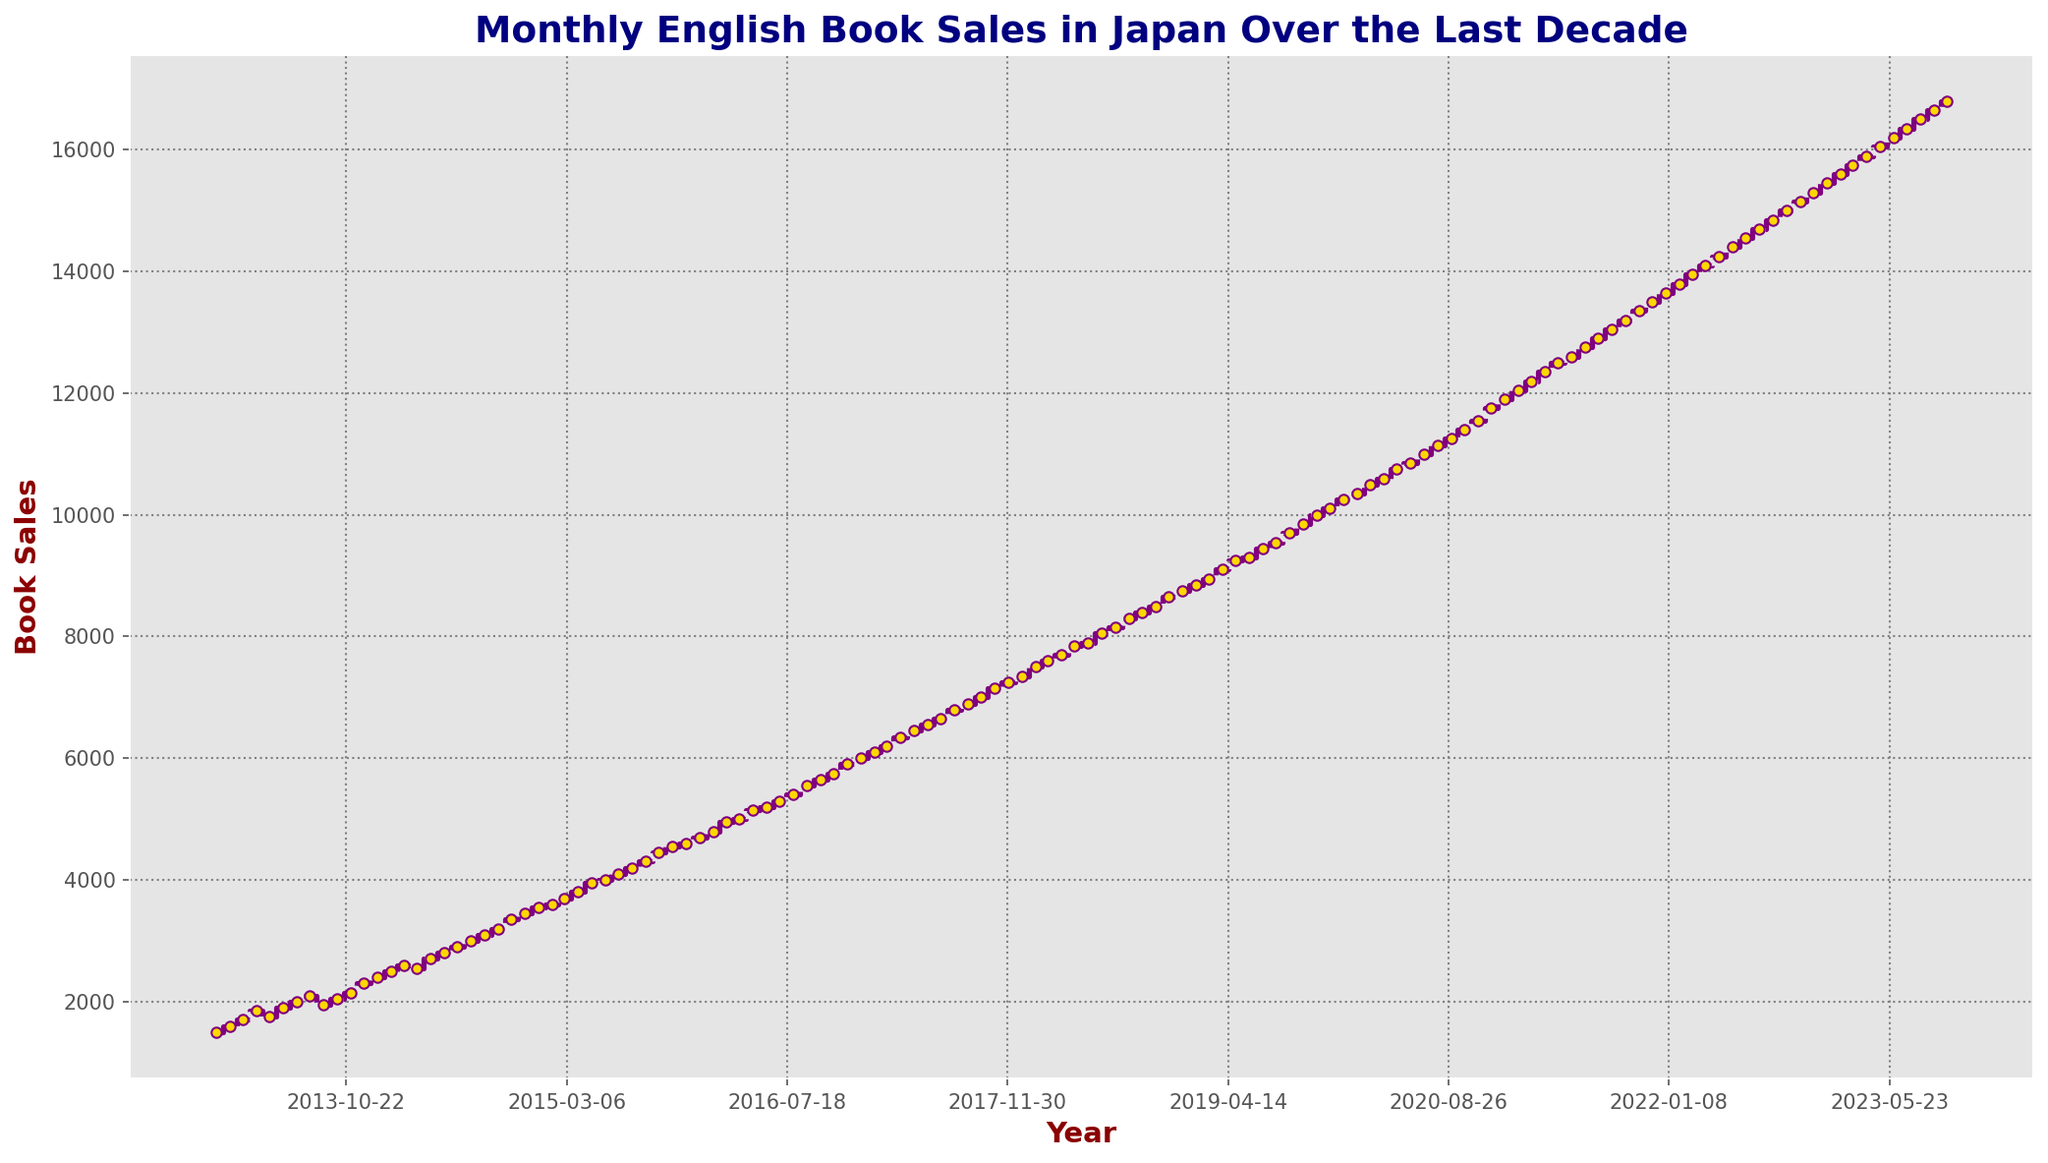How does the book sales trend from January 2015 to January 2017 look? The figure shows the monthly book sales. Moving from January 2015 to January 2017, examine the sales data points and observe their general direction. The sales figures increase over time, indicating an upward trend.
Answer: Upward trend Which month in 2020 saw the highest book sales? Look for the peak point in the 2020 line of the figure. According to the plot, December 2020 shows the peak sales figure for the year.
Answer: December Comparing July 2013 and July 2023, which month had higher book sales, and by how much? Identify the sales value for July 2013 and July 2023. July 2013 had around 2000 book sales, and July 2023 had around 16350. The difference is calculated as 16350 - 2000 = 14350.
Answer: July 2023 by 14350 What is the overall trend from 2013 to 2023? Observe the entire scale of the figure from the beginning to the end. The book sales line generally rises throughout the decade, showing an overall upward trend.
Answer: Upward trend In which year the sales crossed the 10000 mark for the first time? Locate the point in the plot where the sales line crosses the 10000 mark. According to the figure, this event happens in 2019.
Answer: 2019 By approximately how many sales did books sold increase between 2015 and 2020? Identify sales values in January 2015 and January 2020. January 2015 had around 3550 sales, and January 2020 had around 10250 sales. The increase is approximately 10250 - 3550 = 6700.
Answer: 6700 What is the average book sales figures for the year 2021? Extract the sales values for each month of 2021 from the figure: 11900, 12050, 12200, 12350, 12500, 12600, 12750, 12900, 13050, 13200, 13350, and 13500. Sum these values and divide by 12. (11900 + 12050 + 12200 + 12350 + 12500 + 12600 + 12750 + 12900 + 13050 + 13200 + 13350 + 13500) / 12 = 12713.
Answer: 12713 What color is the line representing the book sales in the plot? Refer to the visual attributes of the line. The line is purple.
Answer: Purple Between which consecutive years was the largest increase in book sales? Analyze the changes between each consecutive pair of years. The largest jump appears to be between 2019 and 2020, based on the steepness of the line.
Answer: 2019 and 2020 Did book sales increase or decrease in December 2014 compared to the previous month? Compare the sales figure of November 2014 to December 2014. Sales increased from 3350 in November to 3450 in December.
Answer: Increase 